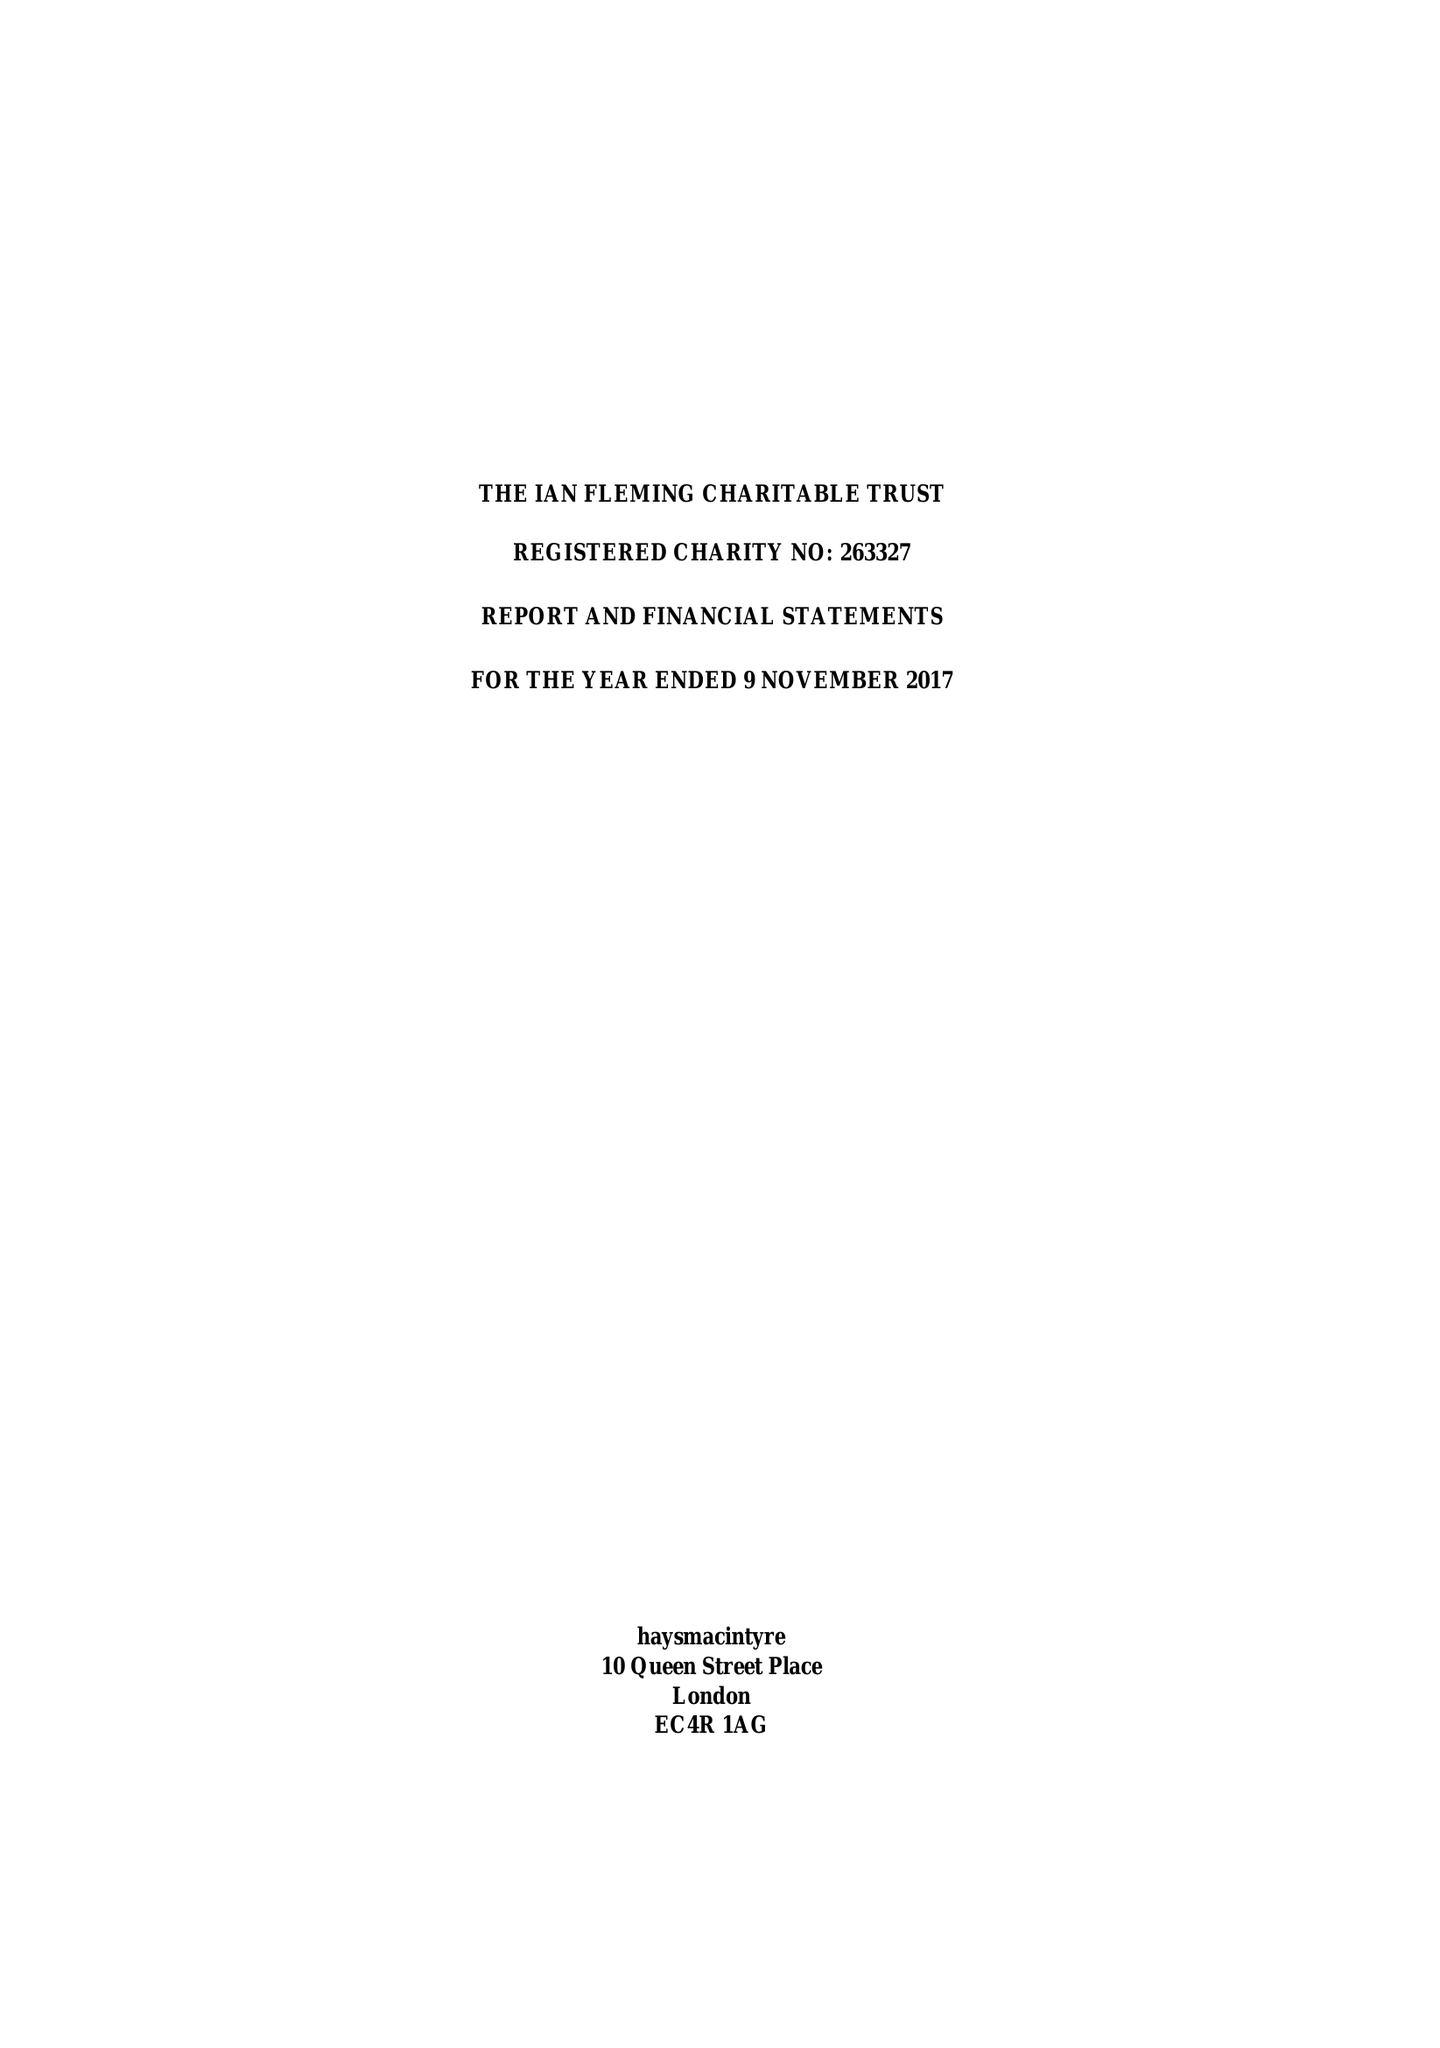What is the value for the income_annually_in_british_pounds?
Answer the question using a single word or phrase. 43346.00 